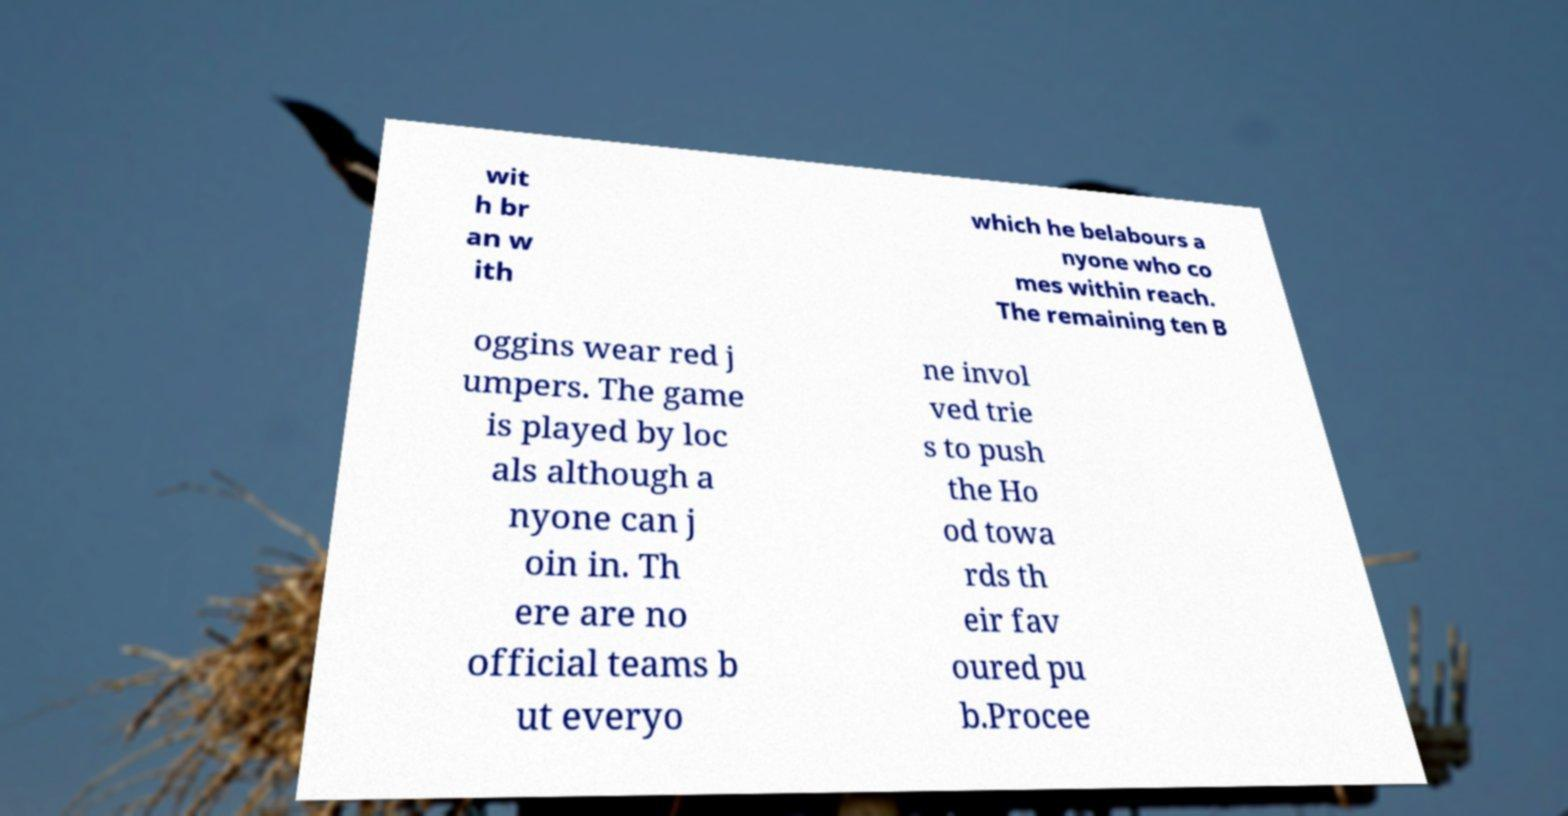There's text embedded in this image that I need extracted. Can you transcribe it verbatim? wit h br an w ith which he belabours a nyone who co mes within reach. The remaining ten B oggins wear red j umpers. The game is played by loc als although a nyone can j oin in. Th ere are no official teams b ut everyo ne invol ved trie s to push the Ho od towa rds th eir fav oured pu b.Procee 